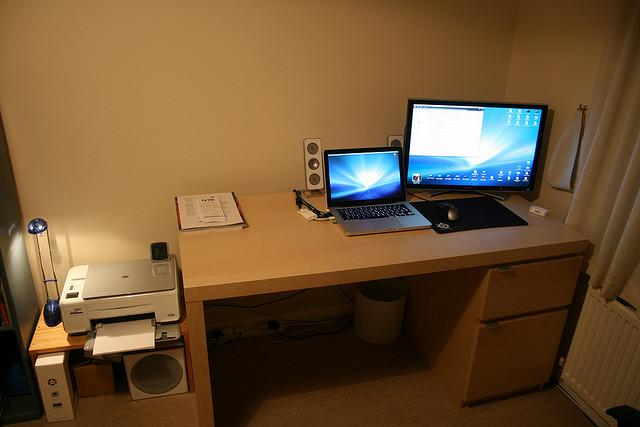What is this desk made of? Please explain your reasoning. laminated wood. It might also have a b core made of c or d. 